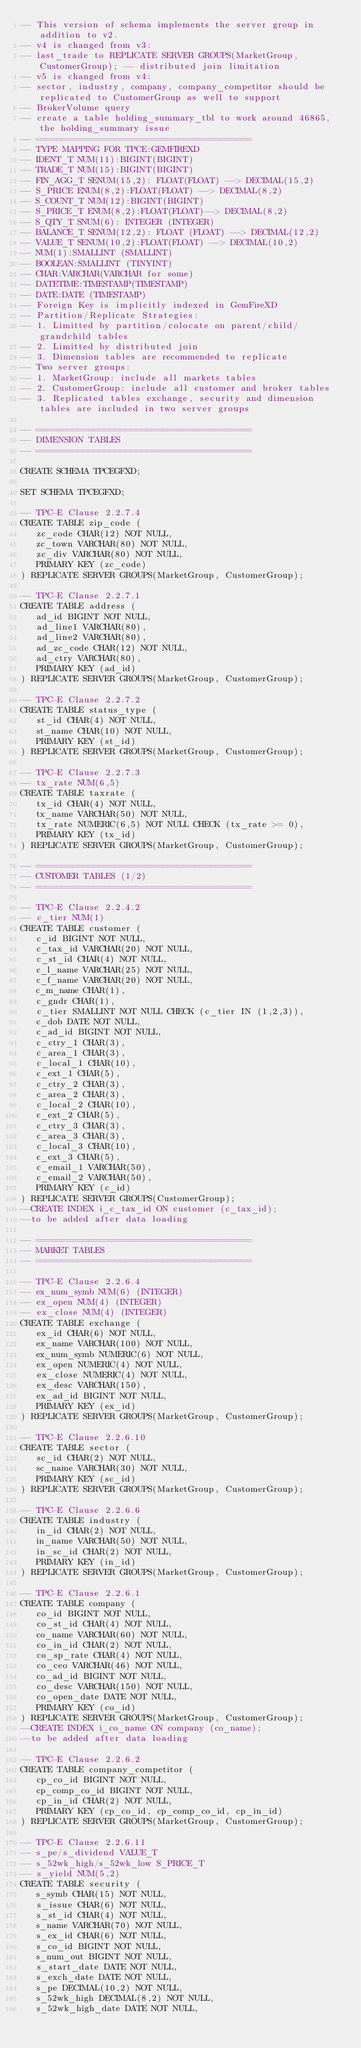<code> <loc_0><loc_0><loc_500><loc_500><_SQL_>-- This version of schema implements the server group in addition to v2.
-- v4 is changed from v3:
-- last_trade to REPLICATE SERVER GROUPS(MarketGroup, CustomerGroup); -- distributed join limitation
-- v5 is changed from v4:
-- sector, industry, company, company_competitor should be replicated to CustomerGroup as well to support
-- BrokerVolume query
-- create a table holding_summary_tbl to work around 46865, the holding_summary issue
-- =========================================
-- TYPE MAPPING FOR TPCE:GEMFIREXD
-- IDENT_T NUM(11):BIGINT(BIGINT)
-- TRADE_T NUM(15):BIGINT(BIGINT)
-- FIN_AGG_T SENUM(15,2): FLOAT(FLOAT) --> DECIMAL(15,2) 
-- S_PRICE ENUM(8,2):FLOAT(FLOAT) --> DECIMAL(8,2) 
-- S_COUNT_T NUM(12):BIGINT(BIGINT)
-- S_PRICE_T ENUM(8,2):FLOAT(FLOAT)--> DECIMAL(8,2) 
-- S_QTY_T SNUM(6): INTEGER (INTEGER)
-- BALANCE_T SENUM(12,2): FLOAT (FLOAT) --> DECIMAL(12,2) 
-- VALUE_T SENUM(10,2):FLOAT(FLOAT) --> DECIMAL(10,2) 
-- NUM(1):SMALLINT (SMALLINT)
-- BOOLEAN:SMALLINT (TINYINT)
-- CHAR:VARCHAR(VARCHAR for some)
-- DATETIME:TIMESTAMP(TIMESTAMP)
-- DATE:DATE (TIMESTAMP)
-- Foreign Key is implicitly indexed in GemFireXD
-- Partition/Replicate Strategies:
-- 1. Limitted by partition/colocate on parent/child/grandchild tables
-- 2. Limitted by distributed join
-- 3. Dimension tables are recommended to replicate
-- Two server groups:
-- 1. MarketGroup: include all markets tables
-- 2. CustomerGroup: include all customer and broker tables
-- 3. Replicated tables exchange, security and dimension tables are included in two server groups

-- =========================================
-- DIMENSION TABLES
-- =========================================

CREATE SCHEMA TPCEGFXD;

SET SCHEMA TPCEGFXD;

-- TPC-E Clause 2.2.7.4
CREATE TABLE zip_code (
   zc_code CHAR(12) NOT NULL,
   zc_town VARCHAR(80) NOT NULL,
   zc_div VARCHAR(80) NOT NULL,
   PRIMARY KEY (zc_code)
) REPLICATE SERVER GROUPS(MarketGroup, CustomerGroup);

-- TPC-E Clause 2.2.7.1
CREATE TABLE address (
   ad_id BIGINT NOT NULL,
   ad_line1 VARCHAR(80),
   ad_line2 VARCHAR(80),
   ad_zc_code CHAR(12) NOT NULL, 
   ad_ctry VARCHAR(80),
   PRIMARY KEY (ad_id)
) REPLICATE SERVER GROUPS(MarketGroup, CustomerGroup);

-- TPC-E Clause 2.2.7.2
CREATE TABLE status_type (
   st_id CHAR(4) NOT NULL,
   st_name CHAR(10) NOT NULL,
   PRIMARY KEY (st_id)
) REPLICATE SERVER GROUPS(MarketGroup, CustomerGroup);

-- TPC-E Clause 2.2.7.3
-- tx_rate NUM(6,5)
CREATE TABLE taxrate (
   tx_id CHAR(4) NOT NULL,
   tx_name VARCHAR(50) NOT NULL,
   tx_rate NUMERIC(6,5) NOT NULL CHECK (tx_rate >= 0),
   PRIMARY KEY (tx_id)
) REPLICATE SERVER GROUPS(MarketGroup, CustomerGroup);

-- =========================================
-- CUSTOMER TABLES (1/2)
-- =========================================

-- TPC-E Clause 2.2.4.2
-- c_tier NUM(1)
CREATE TABLE customer (
   c_id BIGINT NOT NULL,
   c_tax_id VARCHAR(20) NOT NULL,
   c_st_id CHAR(4) NOT NULL, 
   c_l_name VARCHAR(25) NOT NULL,
   c_f_name VARCHAR(20) NOT NULL,
   c_m_name CHAR(1),
   c_gndr CHAR(1),
   c_tier SMALLINT NOT NULL CHECK (c_tier IN (1,2,3)),
   c_dob DATE NOT NULL,
   c_ad_id BIGINT NOT NULL, 
   c_ctry_1 CHAR(3),
   c_area_1 CHAR(3),
   c_local_1 CHAR(10),
   c_ext_1 CHAR(5),
   c_ctry_2 CHAR(3),
   c_area_2 CHAR(3),
   c_local_2 CHAR(10),
   c_ext_2 CHAR(5),
   c_ctry_3 CHAR(3),
   c_area_3 CHAR(3),
   c_local_3 CHAR(10),
   c_ext_3 CHAR(5),
   c_email_1 VARCHAR(50),
   c_email_2 VARCHAR(50),
   PRIMARY KEY (c_id)
) REPLICATE SERVER GROUPS(CustomerGroup);
--CREATE INDEX i_c_tax_id ON customer (c_tax_id);
--to be added after data loading

-- =========================================
-- MARKET TABLES
-- =========================================

-- TPC-E Clause 2.2.6.4
-- ex_num_symb NUM(6) (INTEGER)
-- ex_open NUM(4) (INTEGER)
-- ex_close NUM(4) (INTEGER)
CREATE TABLE exchange (
   ex_id CHAR(6) NOT NULL,
   ex_name VARCHAR(100) NOT NULL,
   ex_num_symb NUMERIC(6) NOT NULL,
   ex_open NUMERIC(4) NOT NULL,
   ex_close NUMERIC(4) NOT NULL,
   ex_desc VARCHAR(150),
   ex_ad_id BIGINT NOT NULL, 
   PRIMARY KEY (ex_id)
) REPLICATE SERVER GROUPS(MarketGroup, CustomerGroup);

-- TPC-E Clause 2.2.6.10
CREATE TABLE sector (
   sc_id CHAR(2) NOT NULL,
   sc_name VARCHAR(30) NOT NULL,
   PRIMARY KEY (sc_id)
) REPLICATE SERVER GROUPS(MarketGroup, CustomerGroup);

-- TPC-E Clause 2.2.6.6
CREATE TABLE industry (
   in_id CHAR(2) NOT NULL,
   in_name VARCHAR(50) NOT NULL,
   in_sc_id CHAR(2) NOT NULL, 
   PRIMARY KEY (in_id)
) REPLICATE SERVER GROUPS(MarketGroup, CustomerGroup);

-- TPC-E Clause 2.2.6.1
CREATE TABLE company (
   co_id BIGINT NOT NULL,
   co_st_id CHAR(4) NOT NULL, 
   co_name VARCHAR(60) NOT NULL,
   co_in_id CHAR(2) NOT NULL, 
   co_sp_rate CHAR(4) NOT NULL,
   co_ceo VARCHAR(46) NOT NULL,
   co_ad_id BIGINT NOT NULL, 
   co_desc VARCHAR(150) NOT NULL,
   co_open_date DATE NOT NULL,
   PRIMARY KEY (co_id)
) REPLICATE SERVER GROUPS(MarketGroup, CustomerGroup);
--CREATE INDEX i_co_name ON company (co_name);
--to be added after data loading

-- TPC-E Clause 2.2.6.2
CREATE TABLE company_competitor (
   cp_co_id BIGINT NOT NULL, 
   cp_comp_co_id BIGINT NOT NULL, 
   cp_in_id CHAR(2) NOT NULL, 
   PRIMARY KEY (cp_co_id, cp_comp_co_id, cp_in_id)
) REPLICATE SERVER GROUPS(MarketGroup, CustomerGroup);

-- TPC-E Clause 2.2.6.11
-- s_pe/s_dividend VALUE_T
-- s_52wk_high/s_52wk_low S_PRICE_T
-- s_yield NUM(5,2)
CREATE TABLE security (
   s_symb CHAR(15) NOT NULL,
   s_issue CHAR(6) NOT NULL,
   s_st_id CHAR(4) NOT NULL, 
   s_name VARCHAR(70) NOT NULL,
   s_ex_id CHAR(6) NOT NULL, 
   s_co_id BIGINT NOT NULL, 
   s_num_out BIGINT NOT NULL,
   s_start_date DATE NOT NULL,
   s_exch_date DATE NOT NULL,
   s_pe DECIMAL(10,2) NOT NULL,
   s_52wk_high DECIMAL(8,2) NOT NULL,
   s_52wk_high_date DATE NOT NULL,</code> 